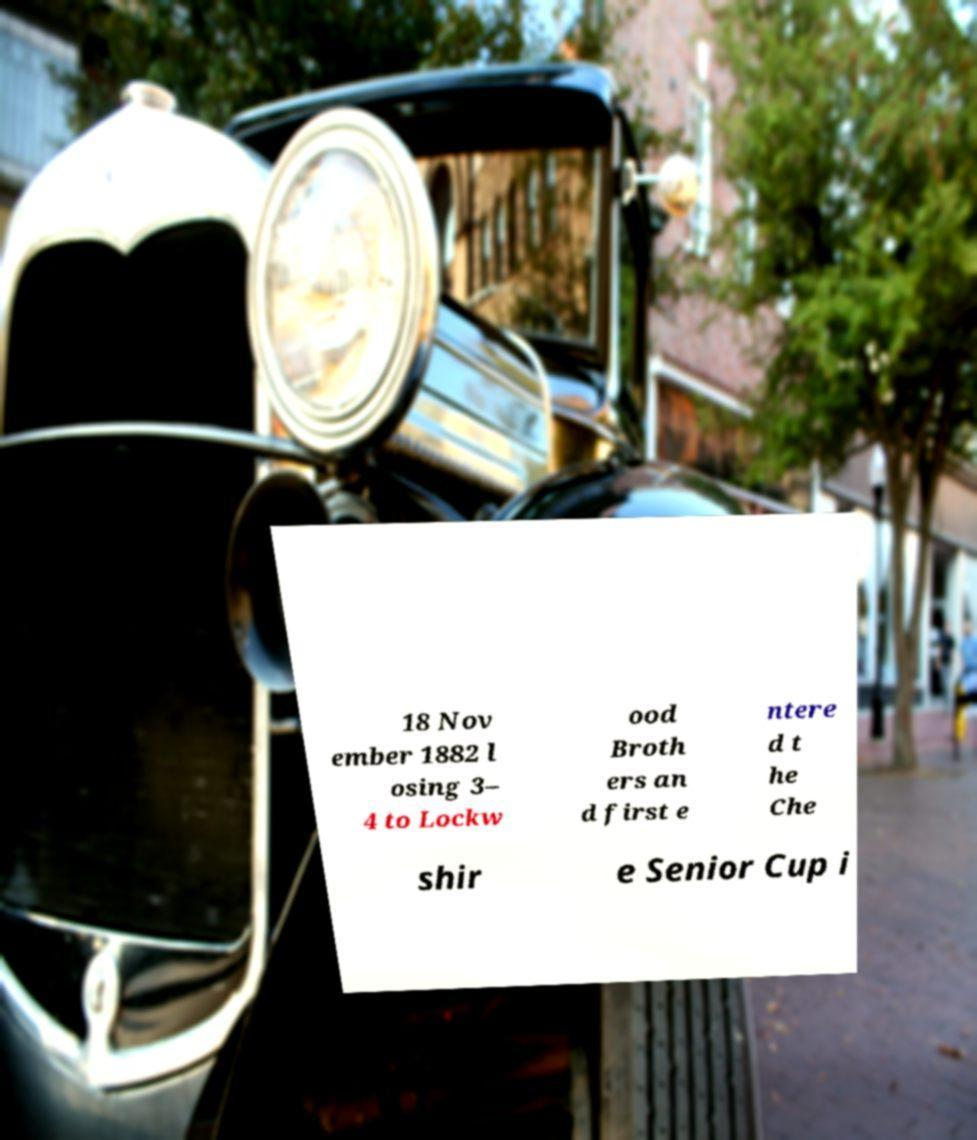I need the written content from this picture converted into text. Can you do that? 18 Nov ember 1882 l osing 3– 4 to Lockw ood Broth ers an d first e ntere d t he Che shir e Senior Cup i 